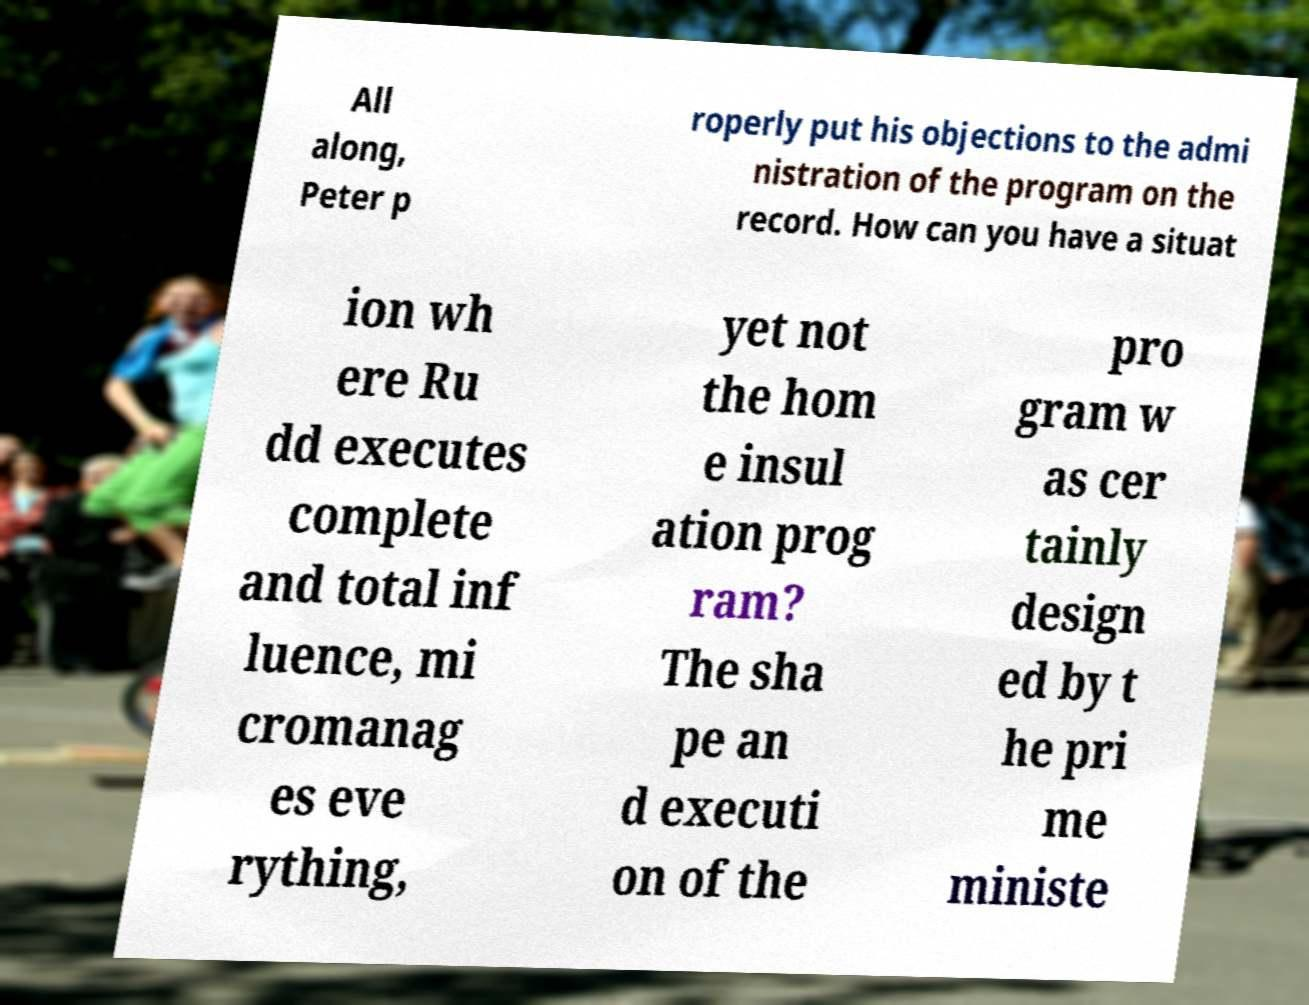Could you assist in decoding the text presented in this image and type it out clearly? All along, Peter p roperly put his objections to the admi nistration of the program on the record. How can you have a situat ion wh ere Ru dd executes complete and total inf luence, mi cromanag es eve rything, yet not the hom e insul ation prog ram? The sha pe an d executi on of the pro gram w as cer tainly design ed by t he pri me ministe 